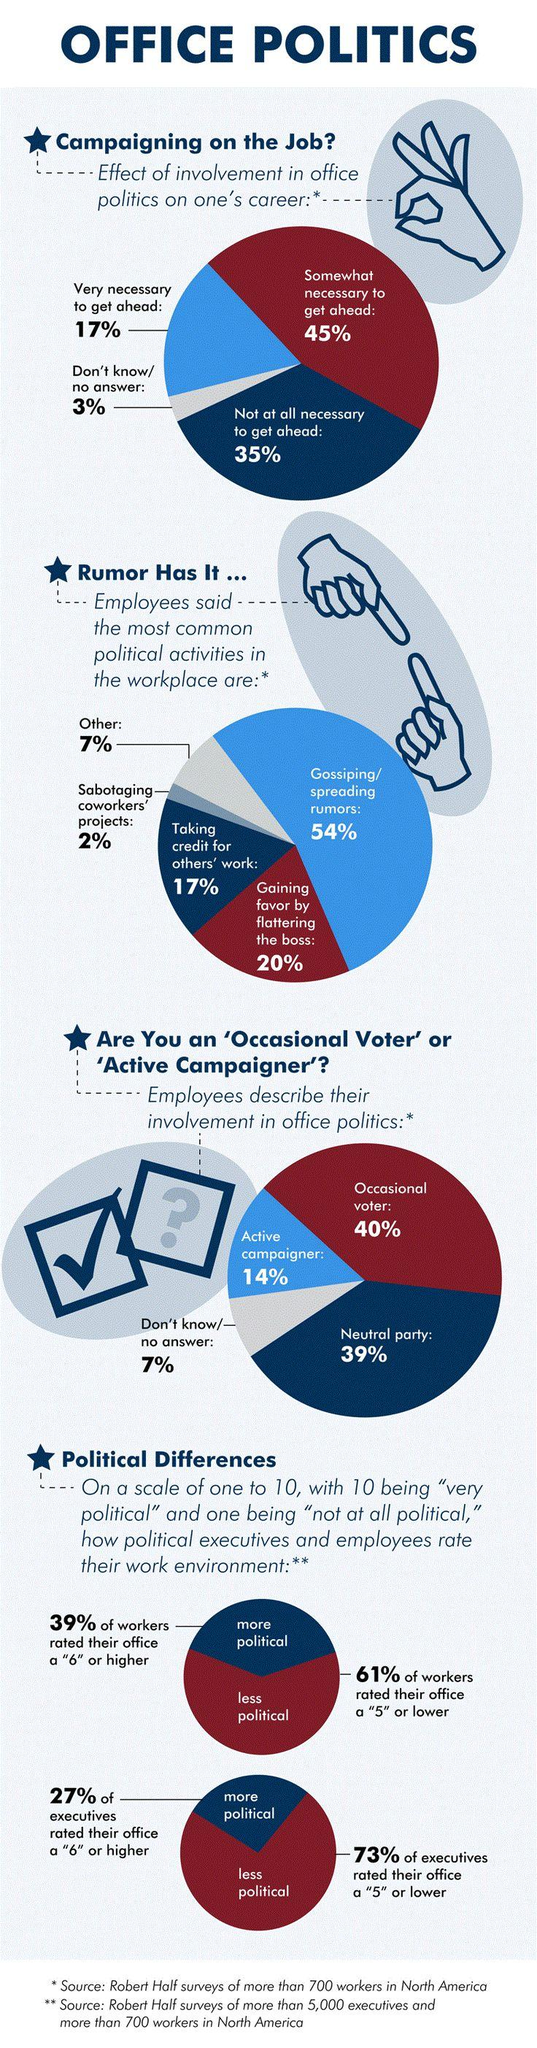Give some essential details in this illustration. According to the survey, 20% of employees believe that gaining favor by flattering the boss is the most common form of political activity in the workplace. The majority of workers rate their work environment as less political. The majority of people believe that office politics are somewhat necessary for one's career progression. According to the data, a substantial 35% of individuals believe that office politics is not at all necessary to advance in their careers. According to the majority of employees, the most common political activity in the workplace is gossiping and spreading rumors. 